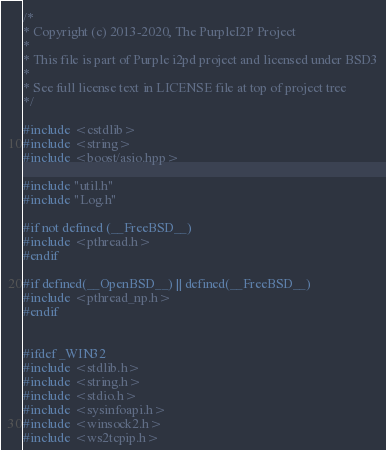Convert code to text. <code><loc_0><loc_0><loc_500><loc_500><_C++_>/*
* Copyright (c) 2013-2020, The PurpleI2P Project
*
* This file is part of Purple i2pd project and licensed under BSD3
*
* See full license text in LICENSE file at top of project tree
*/

#include <cstdlib>
#include <string>
#include <boost/asio.hpp>

#include "util.h"
#include "Log.h"

#if not defined (__FreeBSD__)
#include <pthread.h>
#endif

#if defined(__OpenBSD__) || defined(__FreeBSD__)
#include <pthread_np.h>
#endif


#ifdef _WIN32
#include <stdlib.h>
#include <string.h>
#include <stdio.h>
#include <sysinfoapi.h>
#include <winsock2.h>
#include <ws2tcpip.h></code> 